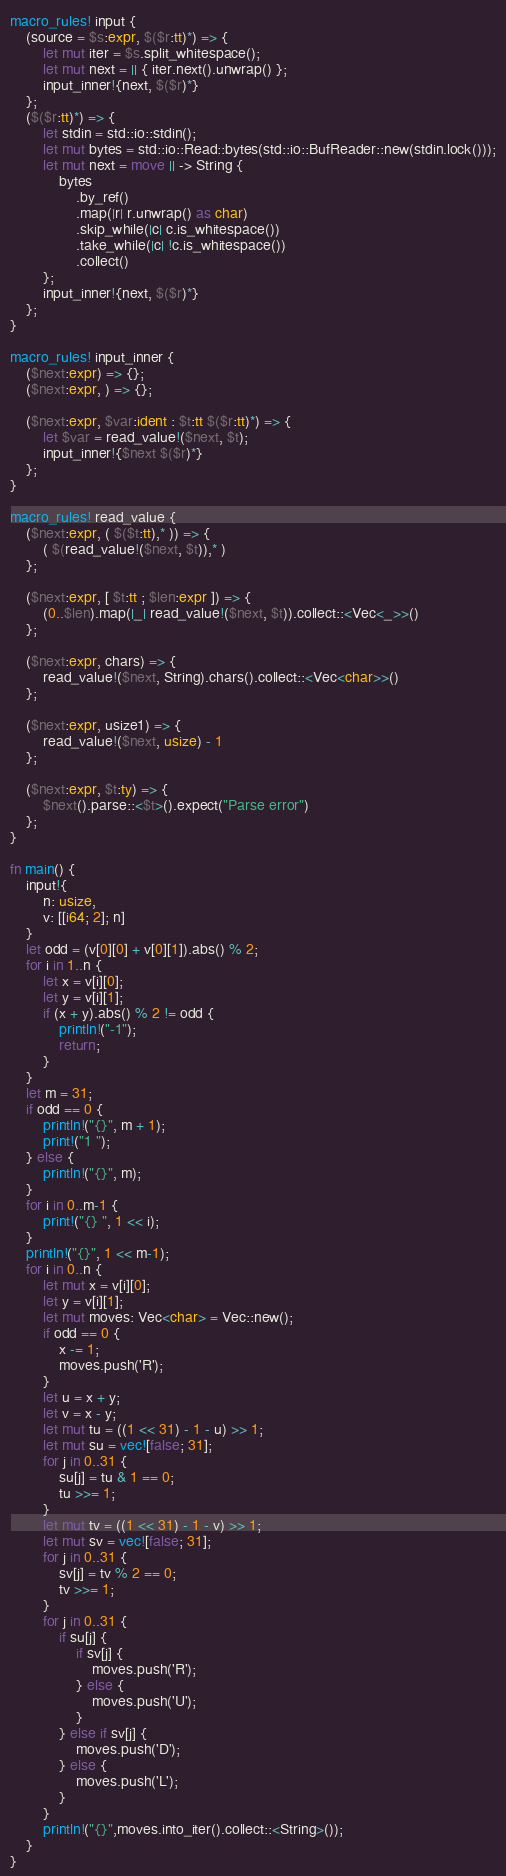Convert code to text. <code><loc_0><loc_0><loc_500><loc_500><_Rust_>macro_rules! input {
    (source = $s:expr, $($r:tt)*) => {
        let mut iter = $s.split_whitespace();
        let mut next = || { iter.next().unwrap() };
        input_inner!{next, $($r)*}
    };
    ($($r:tt)*) => {
        let stdin = std::io::stdin();
        let mut bytes = std::io::Read::bytes(std::io::BufReader::new(stdin.lock()));
        let mut next = move || -> String {
            bytes
                .by_ref()
                .map(|r| r.unwrap() as char)
                .skip_while(|c| c.is_whitespace())
                .take_while(|c| !c.is_whitespace())
                .collect()
        };
        input_inner!{next, $($r)*}
    };
}

macro_rules! input_inner {
    ($next:expr) => {};
    ($next:expr, ) => {};

    ($next:expr, $var:ident : $t:tt $($r:tt)*) => {
        let $var = read_value!($next, $t);
        input_inner!{$next $($r)*}
    };
}

macro_rules! read_value {
    ($next:expr, ( $($t:tt),* )) => {
        ( $(read_value!($next, $t)),* )
    };

    ($next:expr, [ $t:tt ; $len:expr ]) => {
        (0..$len).map(|_| read_value!($next, $t)).collect::<Vec<_>>()
    };

    ($next:expr, chars) => {
        read_value!($next, String).chars().collect::<Vec<char>>()
    };

    ($next:expr, usize1) => {
        read_value!($next, usize) - 1
    };

    ($next:expr, $t:ty) => {
        $next().parse::<$t>().expect("Parse error")
    };
}

fn main() {
    input!{
        n: usize,
        v: [[i64; 2]; n]
    }
    let odd = (v[0][0] + v[0][1]).abs() % 2;
    for i in 1..n {
        let x = v[i][0];
        let y = v[i][1];
        if (x + y).abs() % 2 != odd {
            println!("-1");
            return;
        }
    }
    let m = 31;
    if odd == 0 {
        println!("{}", m + 1);
        print!("1 ");
    } else {
        println!("{}", m);
    }
    for i in 0..m-1 {
        print!("{} ", 1 << i);
    }
    println!("{}", 1 << m-1);
    for i in 0..n {
        let mut x = v[i][0];
        let y = v[i][1];
        let mut moves: Vec<char> = Vec::new();
        if odd == 0 {
            x -= 1;
            moves.push('R');
        }
        let u = x + y;
        let v = x - y;
        let mut tu = ((1 << 31) - 1 - u) >> 1;
        let mut su = vec![false; 31];
        for j in 0..31 {
            su[j] = tu & 1 == 0;
            tu >>= 1;
        }
        let mut tv = ((1 << 31) - 1 - v) >> 1;
        let mut sv = vec![false; 31];
        for j in 0..31 {
            sv[j] = tv % 2 == 0;
            tv >>= 1;
        }
        for j in 0..31 {
            if su[j] {
                if sv[j] {
                    moves.push('R');
                } else {
                    moves.push('U');
                }
            } else if sv[j] {
                moves.push('D');
            } else {
                moves.push('L');
            }
        }
        println!("{}",moves.into_iter().collect::<String>());
    }
}
</code> 